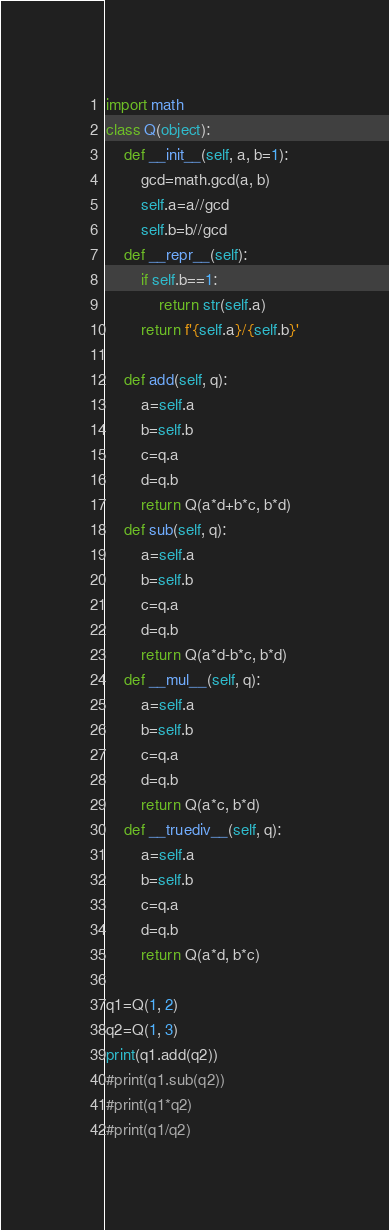<code> <loc_0><loc_0><loc_500><loc_500><_Python_>import math
class Q(object):
    def __init__(self, a, b=1):
        gcd=math.gcd(a, b)
        self.a=a//gcd
        self.b=b//gcd
    def __repr__(self):
        if self.b==1:
            return str(self.a)
        return f'{self.a}/{self.b}'

    def add(self, q):
        a=self.a
        b=self.b
        c=q.a
        d=q.b
        return Q(a*d+b*c, b*d)
    def sub(self, q):
        a=self.a
        b=self.b
        c=q.a
        d=q.b
        return Q(a*d-b*c, b*d)
    def __mul__(self, q):
        a=self.a
        b=self.b
        c=q.a
        d=q.b
        return Q(a*c, b*d)
    def __truediv__(self, q):
        a=self.a
        b=self.b
        c=q.a
        d=q.b
        return Q(a*d, b*c)

q1=Q(1, 2)
q2=Q(1, 3)
print(q1.add(q2))
#print(q1.sub(q2))
#print(q1*q2)
#print(q1/q2)</code> 